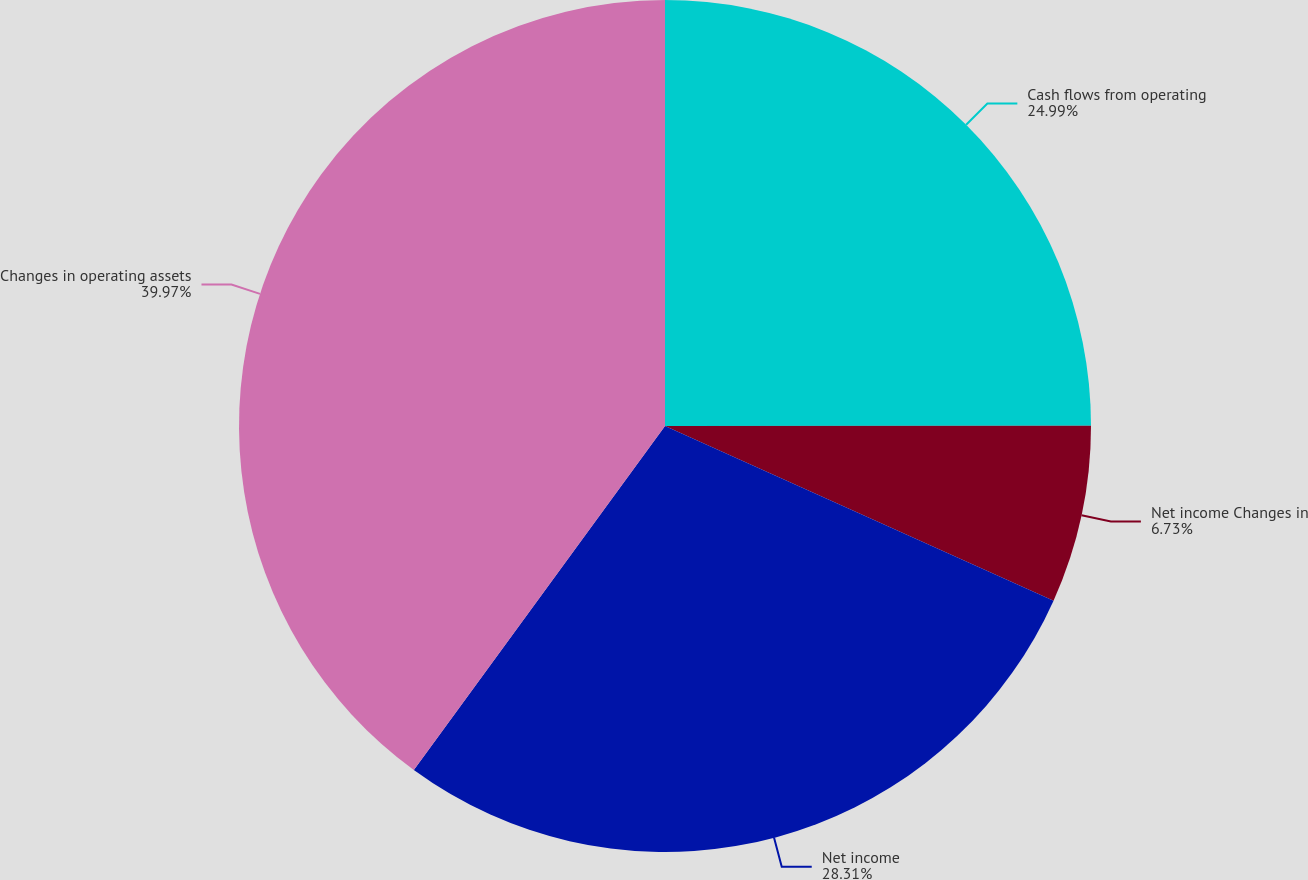Convert chart. <chart><loc_0><loc_0><loc_500><loc_500><pie_chart><fcel>Cash flows from operating<fcel>Net income Changes in<fcel>Net income<fcel>Changes in operating assets<nl><fcel>24.99%<fcel>6.73%<fcel>28.31%<fcel>39.96%<nl></chart> 